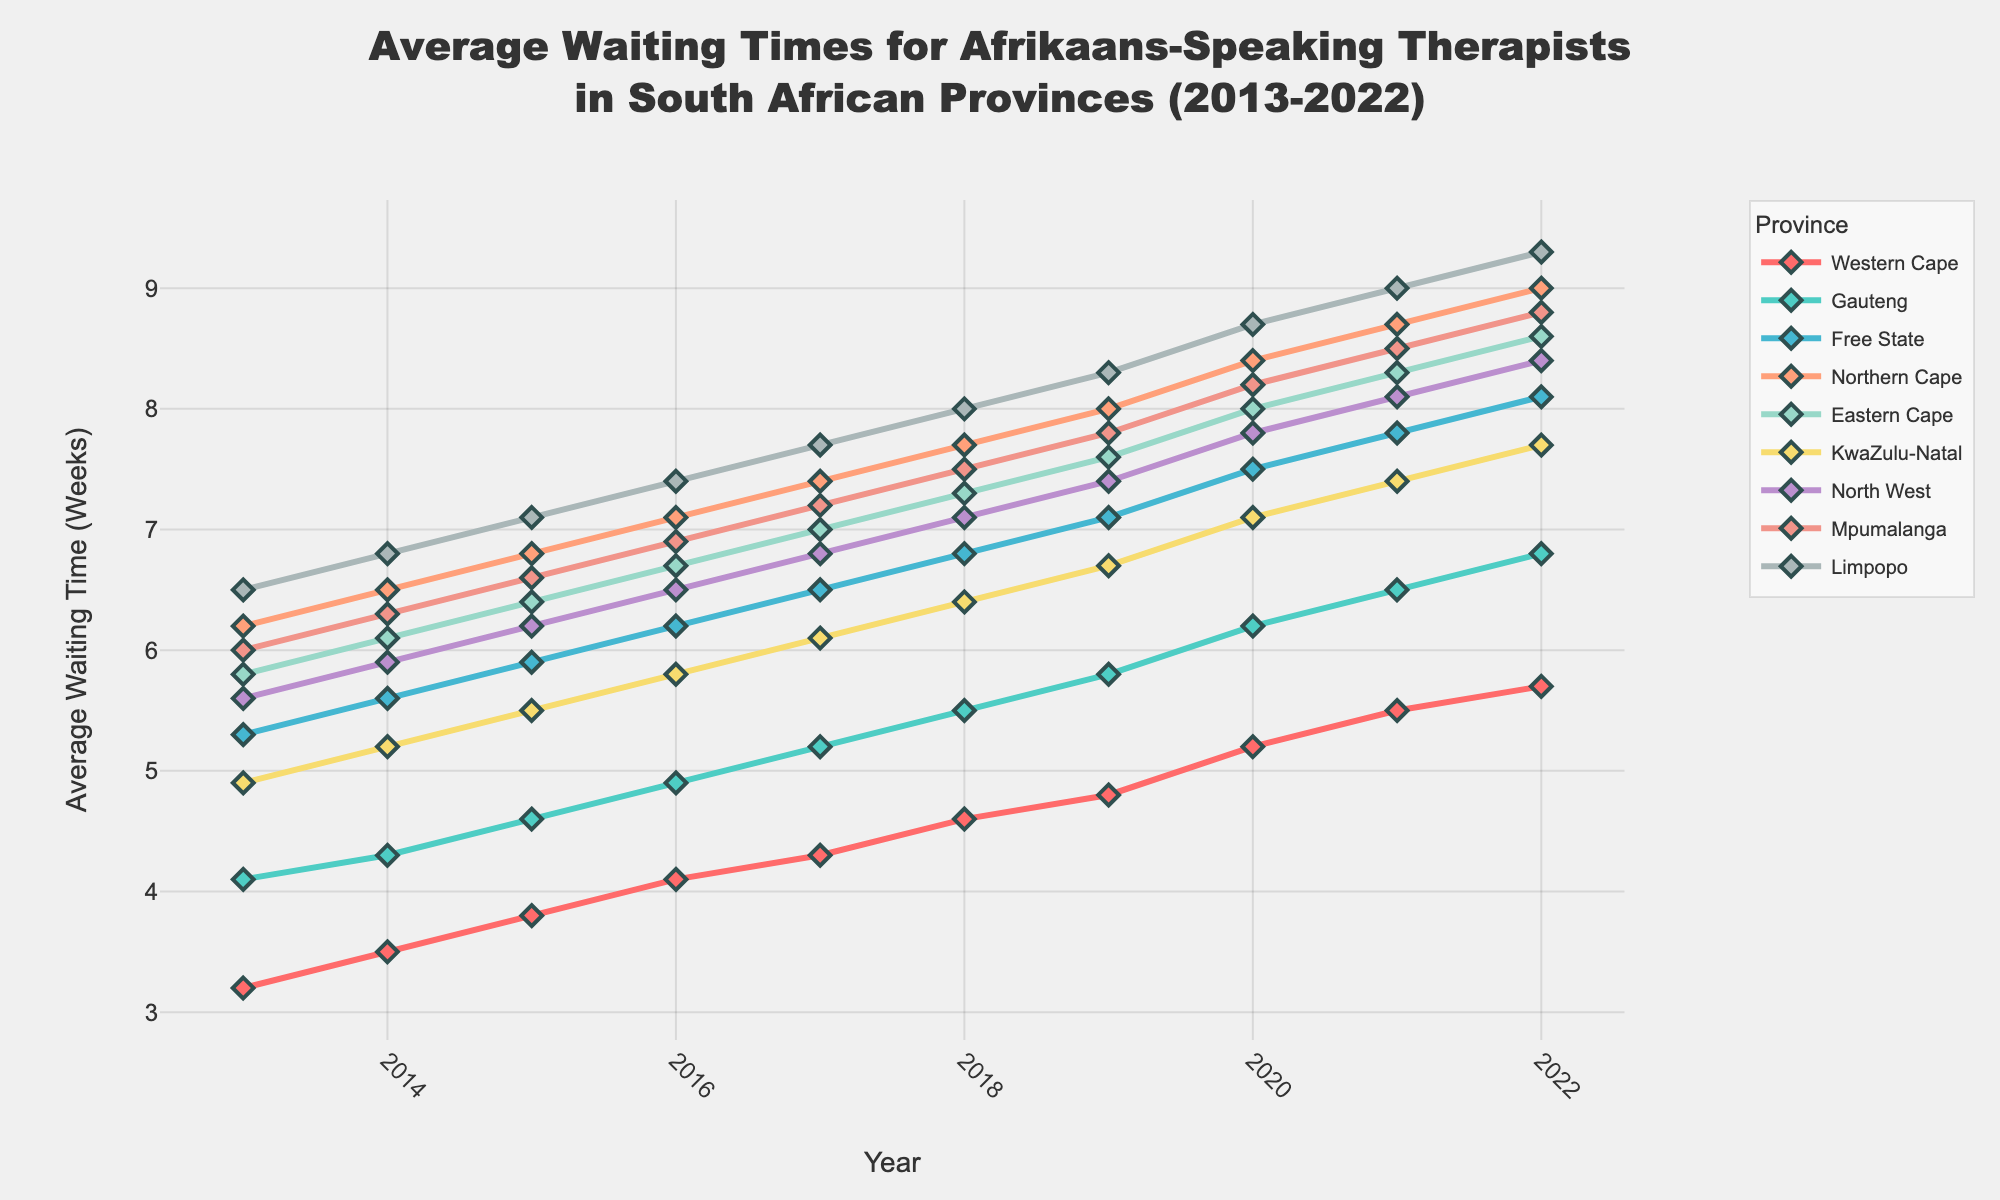What's the average waiting time for Gauteng in 2013 and 2022? To find the average waiting time for Gauteng in 2013 and 2022, you add the values for those years (4.1 + 6.8) and then divide by 2.
Answer: 5.45 Which province had the longest average waiting time in 2022? By looking at the y-coordinate for 2022 for each province, Limpopo had the longest waiting time at 9.3 weeks.
Answer: Limpopo What is the difference between the average waiting times of Western Cape and Northern Cape in 2020? Looking at the values for 2020, Western Cape has 5.2 and Northern Cape has 8.4. Subtract the smaller value from the larger one to get 8.4 - 5.2 = 3.2.
Answer: 3.2 Which province showed the greatest increase in average waiting time between 2013 and 2022? Calculate the difference between 2013 and 2022 values for each province and find which difference is greatest. Limpopo increased from 6.5 to 9.3, a difference of 2.8. This is the highest increase among the provinces.
Answer: Limpopo Among the provinces, which one had the least increase in waiting time from 2013 to 2022? Calculate the difference between the 2013 and 2022 values for each province. Western Cape had the least increase from 3.2 in 2013 to 5.7 in 2022, which is an increase of 2.5.
Answer: Western Cape By how many weeks did the waiting time increase in Mpumalanga from 2018 to 2021? In Mpumalanga, the waiting time in 2018 was 7.5 weeks and in 2021 it was 8.5 weeks. The increase is 8.5 - 7.5 = 1 week.
Answer: 1 Which two provinces had the closest average waiting times in 2019 and what were they? By inspecting the 2019 values, the closest average waiting times are Gauteng (5.8) and Western Cape (4.8), with a difference of 1 week.
Answer: Gauteng and Western Cape In 2022, which province had the third highest average waiting time? By ordering the 2022 values, the third highest waiting time is in Mpumalanga at 8.8 weeks, after Limpopo and Northern Cape.
Answer: Mpumalanga What is the trend in average waiting time for KwaZulu-Natal from 2013 to 2022? Observing the line for KwaZulu-Natal, it shows a consistent upward trend from 2013 (4.9) to 2022 (7.7).
Answer: Upward How does the average waiting time in 2022 for Free State compare to Northern Cape? The average waiting time in 2022 for Free State is 8.1 weeks while it is 9.0 weeks for Northern Cape. Free State's waiting time is 0.9 weeks less than Northern Cape's.
Answer: Less by 0.9 weeks 